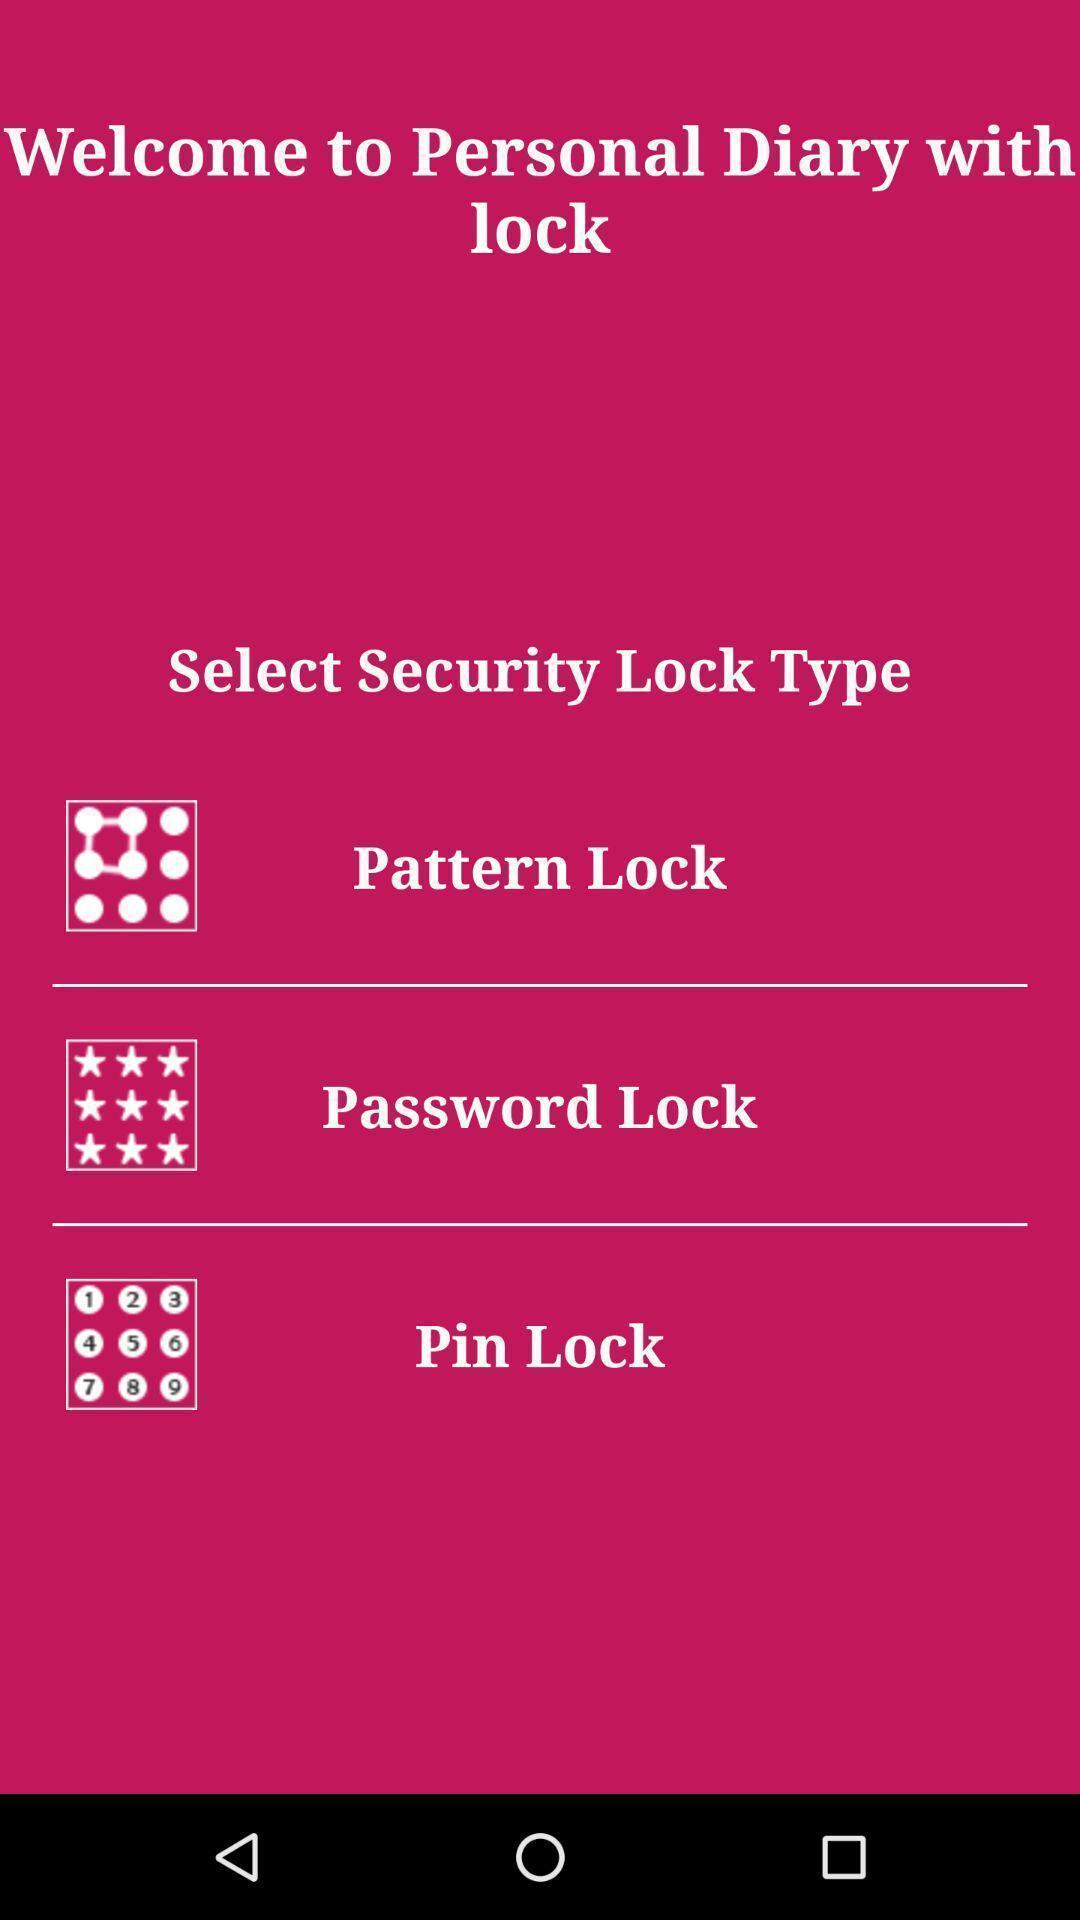Describe this image in words. Welcome page. 